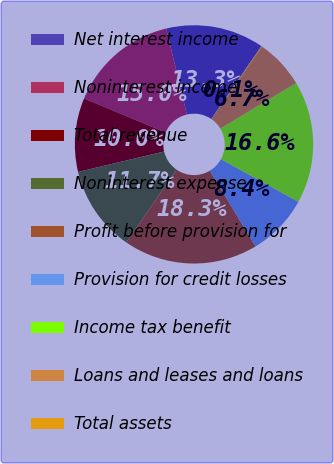Convert chart. <chart><loc_0><loc_0><loc_500><loc_500><pie_chart><fcel>Net interest income<fcel>Noninterest income<fcel>Total revenue<fcel>Noninterest expense<fcel>Profit before provision for<fcel>Provision for credit losses<fcel>Income tax benefit<fcel>Loans and leases and loans<fcel>Total assets<nl><fcel>13.31%<fcel>14.96%<fcel>10.01%<fcel>11.66%<fcel>18.26%<fcel>8.36%<fcel>16.61%<fcel>6.71%<fcel>0.11%<nl></chart> 